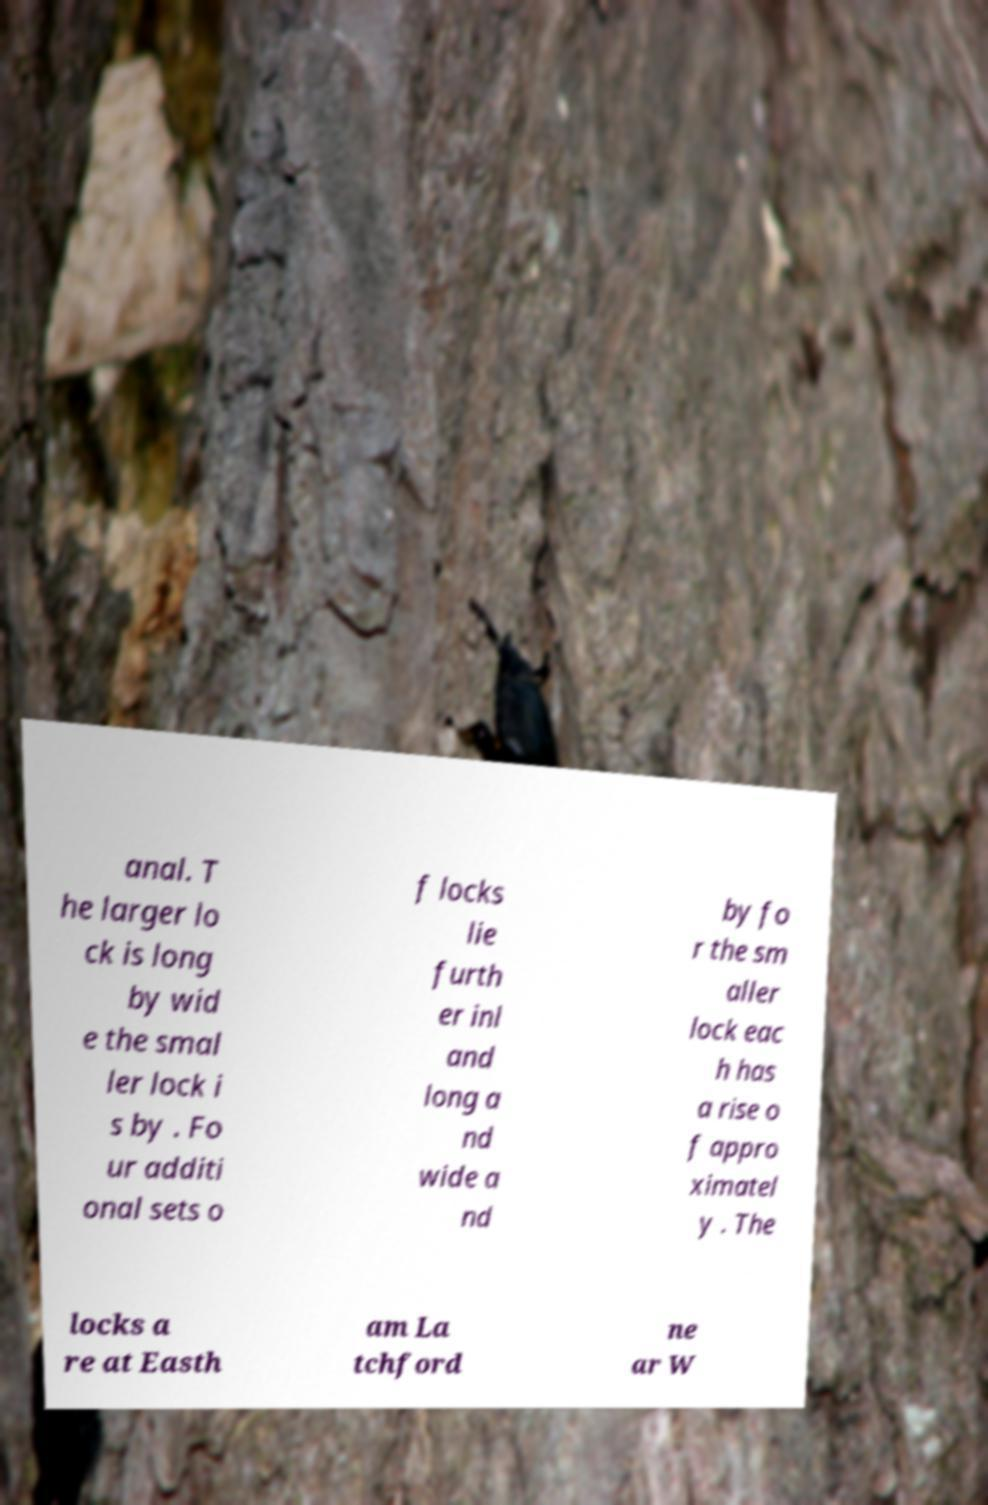There's text embedded in this image that I need extracted. Can you transcribe it verbatim? anal. T he larger lo ck is long by wid e the smal ler lock i s by . Fo ur additi onal sets o f locks lie furth er inl and long a nd wide a nd by fo r the sm aller lock eac h has a rise o f appro ximatel y . The locks a re at Easth am La tchford ne ar W 